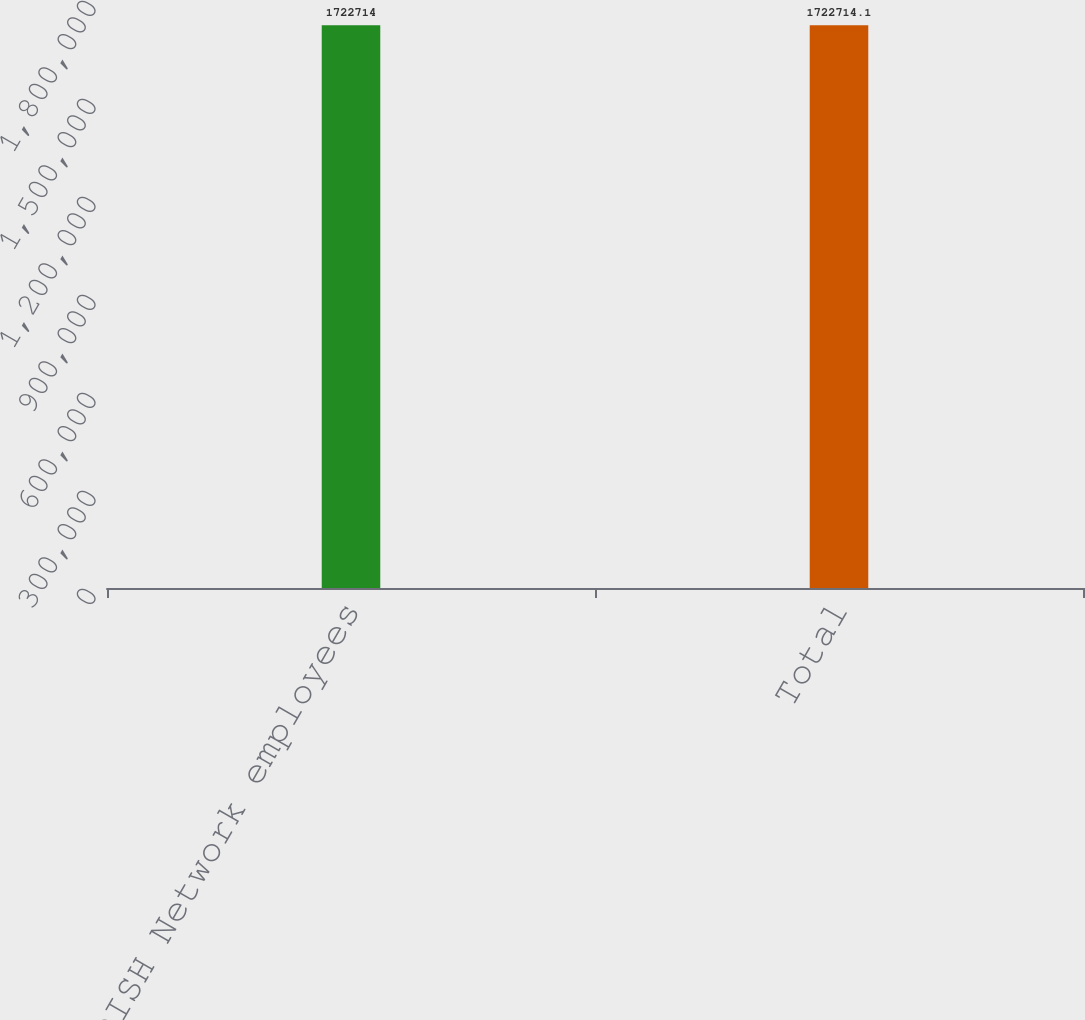Convert chart to OTSL. <chart><loc_0><loc_0><loc_500><loc_500><bar_chart><fcel>Held by DISH Network employees<fcel>Total<nl><fcel>1.72271e+06<fcel>1.72271e+06<nl></chart> 